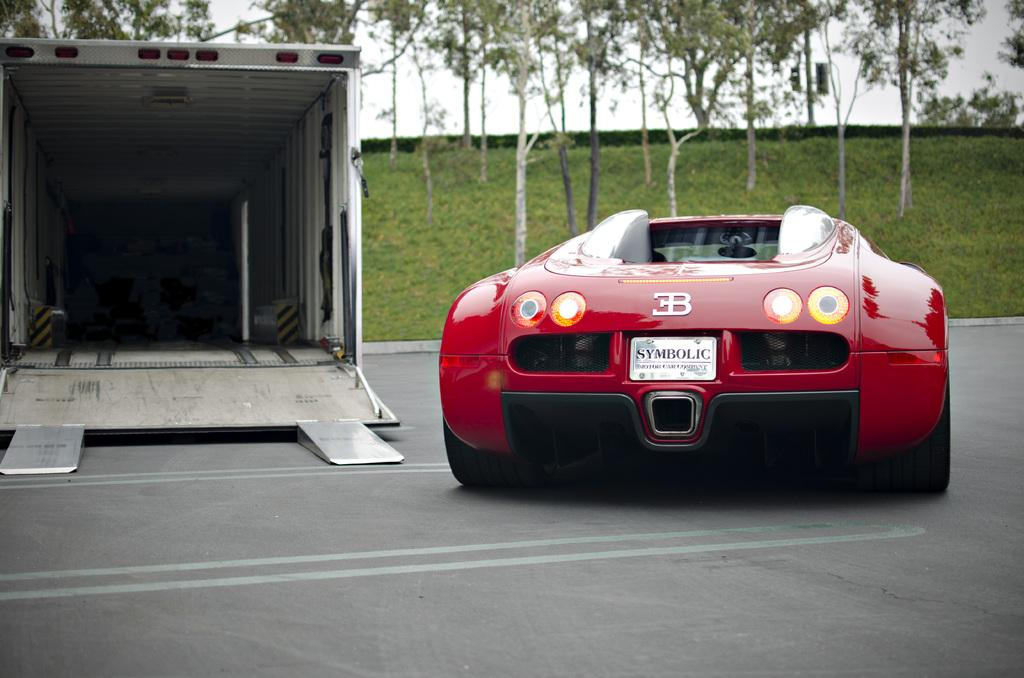What type of vehicle is in the picture? There is a red color car in the picture. What structure can be seen on the left side of the picture? There is a shed on the left side of the picture. What type of vegetation is visible in the background of the picture? There are trees and grass in the background of the picture. What is visible at the top of the picture? The sky is visible at the top of the picture. Can you see a river flowing in the background of the picture? There is no river visible in the background of the picture; it features trees, grass, and the sky. What type of star is shining on the car in the picture? There is no star present in the picture; it only shows a red car, a shed, trees, grass, and the sky. 